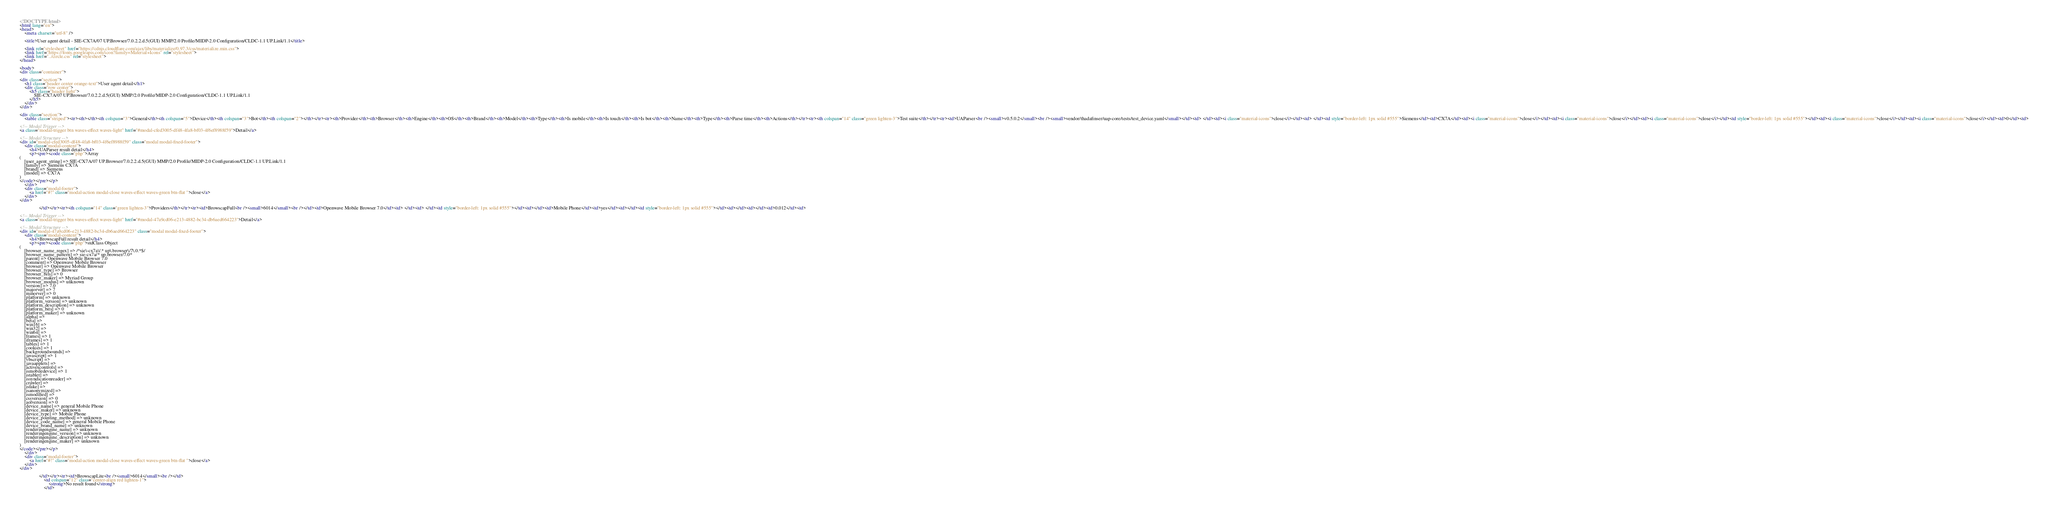Convert code to text. <code><loc_0><loc_0><loc_500><loc_500><_HTML_>
<!DOCTYPE html>
<html lang="en">
<head>
    <meta charset="utf-8" />
            
    <title>User agent detail - SIE-CX7A/07 UP.Browser/7.0.2.2.d.5(GUI) MMP/2.0 Profile/MIDP-2.0 Configuration/CLDC-1.1 UP.Link/1.1</title>
        
    <link rel="stylesheet" href="https://cdnjs.cloudflare.com/ajax/libs/materialize/0.97.3/css/materialize.min.css">
    <link href="https://fonts.googleapis.com/icon?family=Material+Icons" rel="stylesheet">
    <link href="../circle.css" rel="stylesheet">
</head>
        
<body>
<div class="container">
    
<div class="section">
	<h1 class="header center orange-text">User agent detail</h1>
	<div class="row center">
        <h5 class="header light">
            SIE-CX7A/07 UP.Browser/7.0.2.2.d.5(GUI) MMP/2.0 Profile/MIDP-2.0 Configuration/CLDC-1.1 UP.Link/1.1
        </h5>
	</div>
</div>   

<div class="section">
    <table class="striped"><tr><th></th><th colspan="3">General</th><th colspan="5">Device</th><th colspan="3">Bot</th><th colspan="2"></th></tr><tr><th>Provider</th><th>Browser</th><th>Engine</th><th>OS</th><th>Brand</th><th>Model</th><th>Type</th><th>Is mobile</th><th>Is touch</th><th>Is bot</th><th>Name</th><th>Type</th><th>Parse time</th><th>Actions</th></tr><tr><th colspan="14" class="green lighten-3">Test suite</th></tr><tr><td>UAParser<br /><small>v0.5.0.2</small><br /><small>vendor/thadafinser/uap-core/tests/test_device.yaml</small></td><td> </td><td><i class="material-icons">close</i></td><td> </td><td style="border-left: 1px solid #555">Siemens</td><td>CX7A</td><td><i class="material-icons">close</i></td><td><i class="material-icons">close</i></td><td><i class="material-icons">close</i></td><td style="border-left: 1px solid #555"></td><td><i class="material-icons">close</i></td><td><i class="material-icons">close</i></td><td>0</td><td>
        
<!-- Modal Trigger -->
<a class="modal-trigger btn waves-effect waves-light" href="#modal-cfed3005-df48-4fa8-bf03-4f6ef8988f59">Detail</a>
        
<!-- Modal Structure -->
<div id="modal-cfed3005-df48-4fa8-bf03-4f6ef8988f59" class="modal modal-fixed-footer">
    <div class="modal-content">
        <h4>UAParser result detail</h4>
        <p><pre><code class="php">Array
(
    [user_agent_string] => SIE-CX7A/07 UP.Browser/7.0.2.2.d.5(GUI) MMP/2.0 Profile/MIDP-2.0 Configuration/CLDC-1.1 UP.Link/1.1
    [family] => Siemens CX7A
    [brand] => Siemens
    [model] => CX7A
)
</code></pre></p>
    </div>
    <div class="modal-footer">
        <a href="#!" class="modal-action modal-close waves-effect waves-green btn-flat ">close</a>
    </div>
</div>
        
                </td></tr><tr><th colspan="14" class="green lighten-3">Providers</th></tr><tr><td>BrowscapFull<br /><small>6014</small><br /></td><td>Openwave Mobile Browser 7.0</td><td> </td><td> </td><td style="border-left: 1px solid #555"></td><td></td><td>Mobile Phone</td><td>yes</td><td></td><td style="border-left: 1px solid #555"></td><td></td><td></td><td>0.012</td><td>
        
<!-- Modal Trigger -->
<a class="modal-trigger btn waves-effect waves-light" href="#modal-47a9cd06-e213-4882-bc34-db6aed664223">Detail</a>
        
<!-- Modal Structure -->
<div id="modal-47a9cd06-e213-4882-bc34-db6aed664223" class="modal modal-fixed-footer">
    <div class="modal-content">
        <h4>BrowscapFull result detail</h4>
        <p><pre><code class="php">stdClass Object
(
    [browser_name_regex] => /^sie\-cx7a\/.* up\.browser\/7\.0.*$/
    [browser_name_pattern] => sie-cx7a/* up.browser/7.0*
    [parent] => Openwave Mobile Browser 7.0
    [comment] => Openwave Mobile Browser
    [browser] => Openwave Mobile Browser
    [browser_type] => Browser
    [browser_bits] => 0
    [browser_maker] => Myriad Group
    [browser_modus] => unknown
    [version] => 7.0
    [majorver] => 7
    [minorver] => 0
    [platform] => unknown
    [platform_version] => unknown
    [platform_description] => unknown
    [platform_bits] => 0
    [platform_maker] => unknown
    [alpha] => 
    [beta] => 
    [win16] => 
    [win32] => 
    [win64] => 
    [frames] => 1
    [iframes] => 1
    [tables] => 1
    [cookies] => 1
    [backgroundsounds] => 
    [javascript] => 1
    [vbscript] => 
    [javaapplets] => 
    [activexcontrols] => 
    [ismobiledevice] => 1
    [istablet] => 
    [issyndicationreader] => 
    [crawler] => 
    [isfake] => 
    [isanonymized] => 
    [ismodified] => 
    [cssversion] => 0
    [aolversion] => 0
    [device_name] => general Mobile Phone
    [device_maker] => unknown
    [device_type] => Mobile Phone
    [device_pointing_method] => unknown
    [device_code_name] => general Mobile Phone
    [device_brand_name] => unknown
    [renderingengine_name] => unknown
    [renderingengine_version] => unknown
    [renderingengine_description] => unknown
    [renderingengine_maker] => unknown
)
</code></pre></p>
    </div>
    <div class="modal-footer">
        <a href="#!" class="modal-action modal-close waves-effect waves-green btn-flat ">close</a>
    </div>
</div>
        
                </td></tr><tr><td>BrowscapLite<br /><small>6014</small><br /></td>
                    <td colspan="12" class="center-align red lighten-1">
                        <strong>No result found</strong>
                    </td></code> 